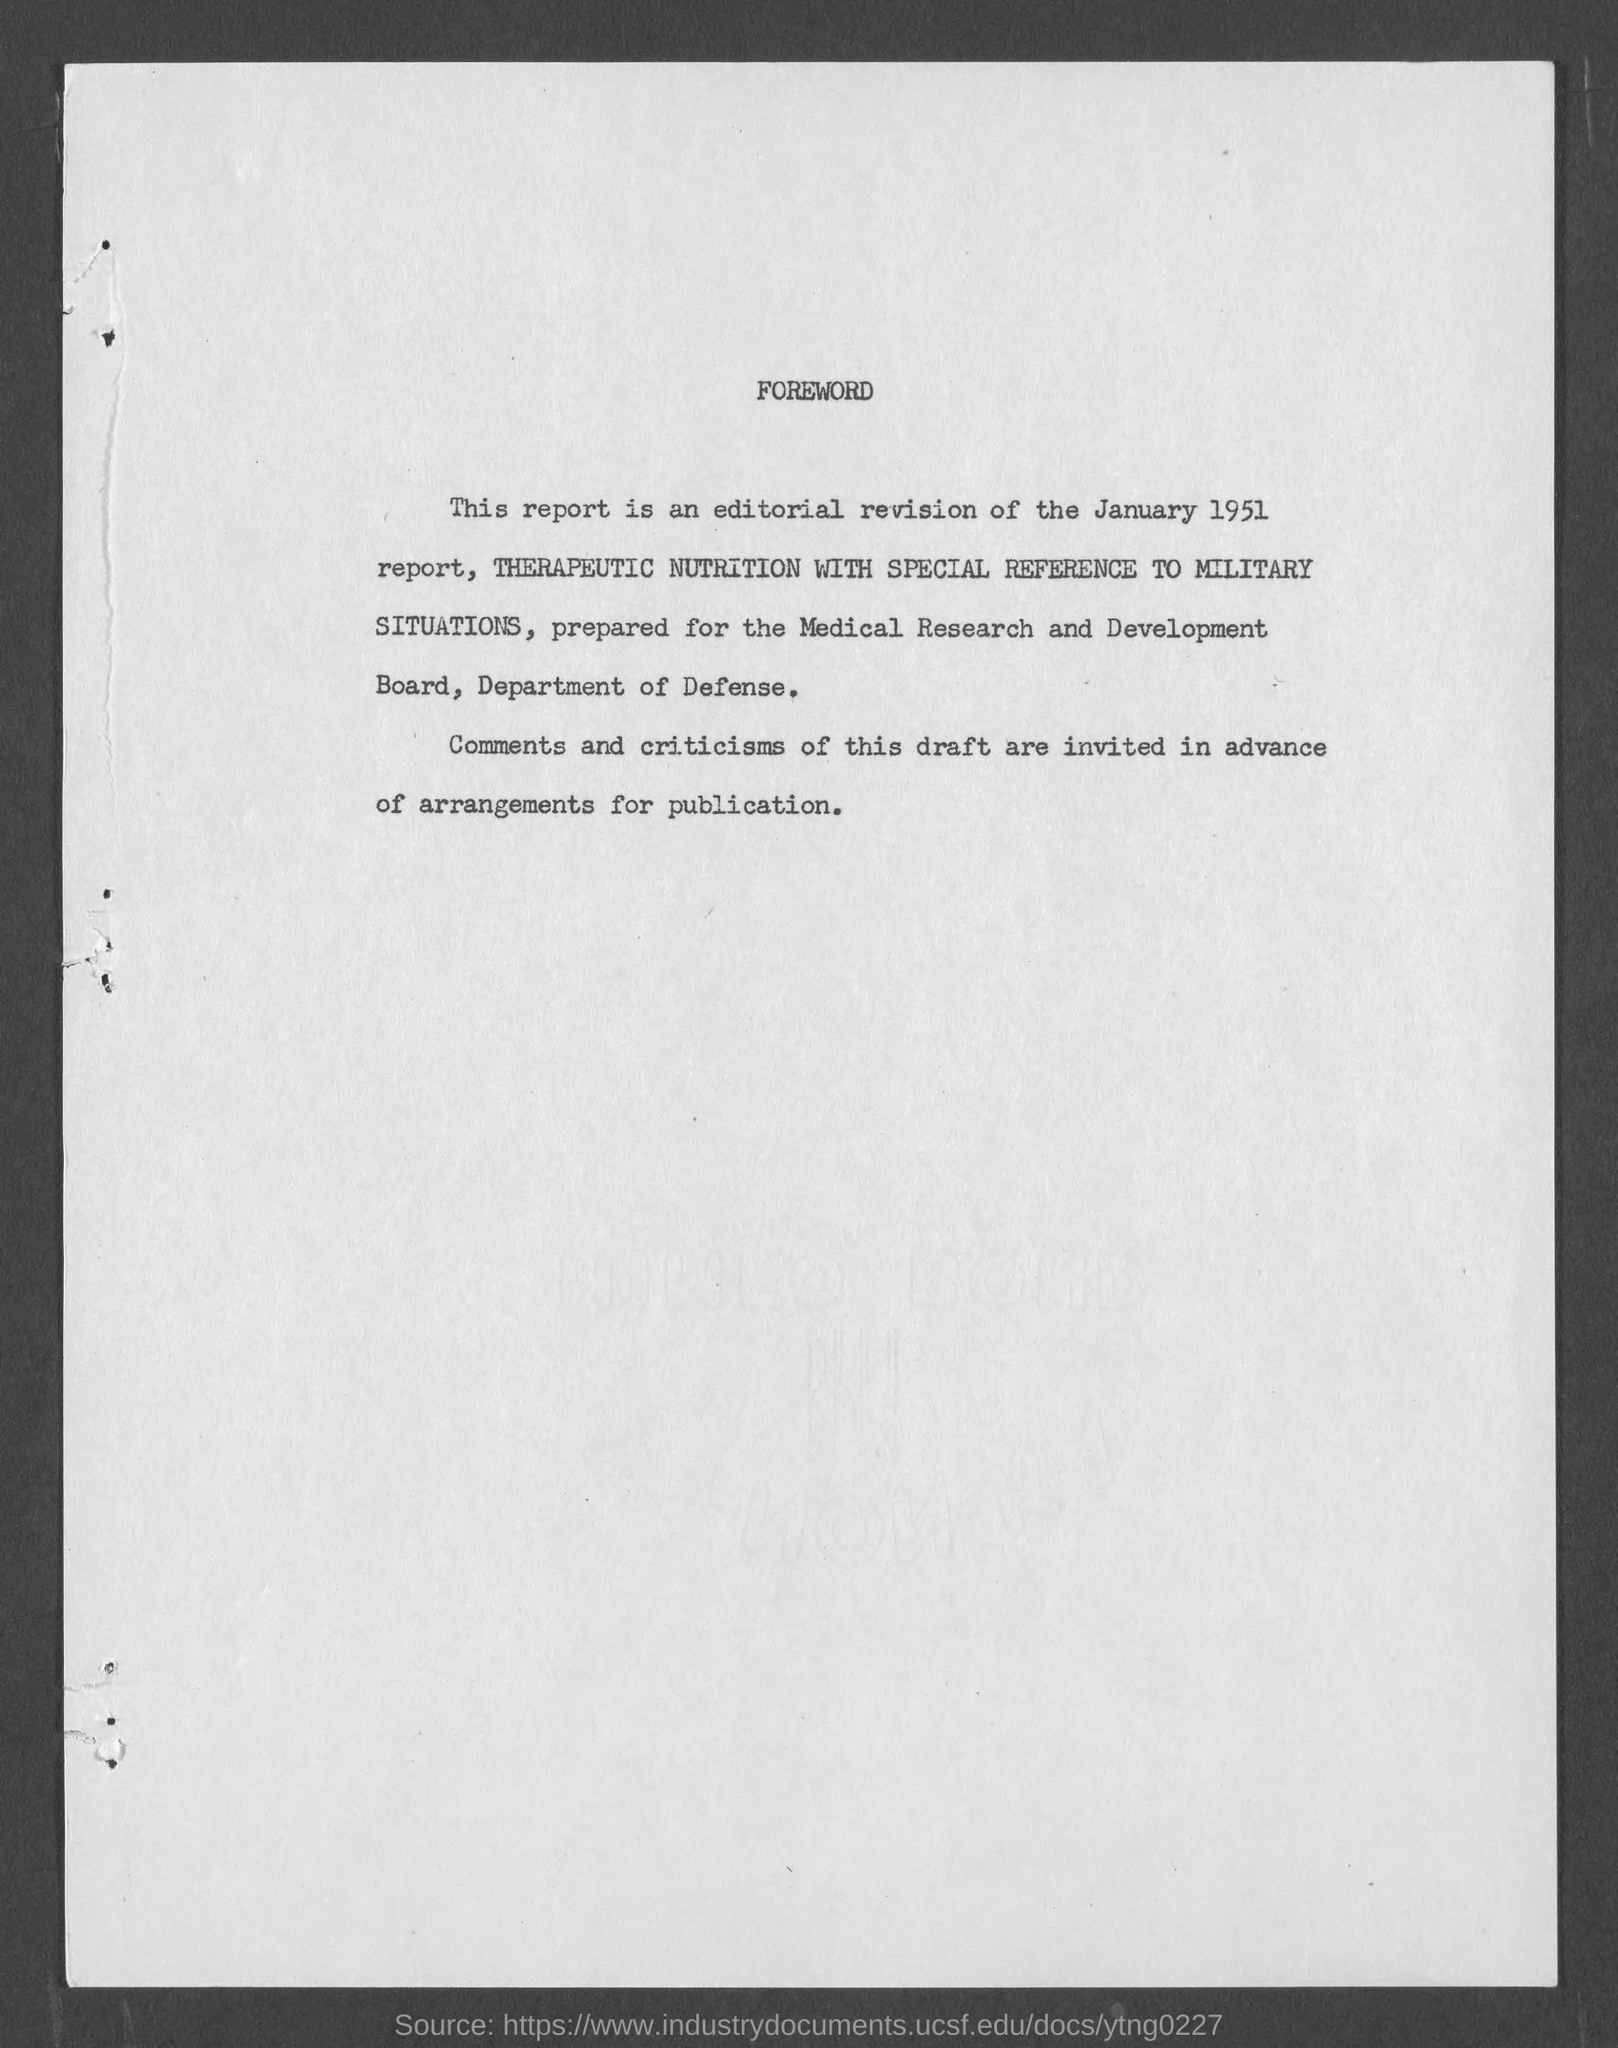For whom did this report prepared?
Your response must be concise. Medical research and development board, Department of defense. What is the date of this report?
Offer a terse response. January 1951. 